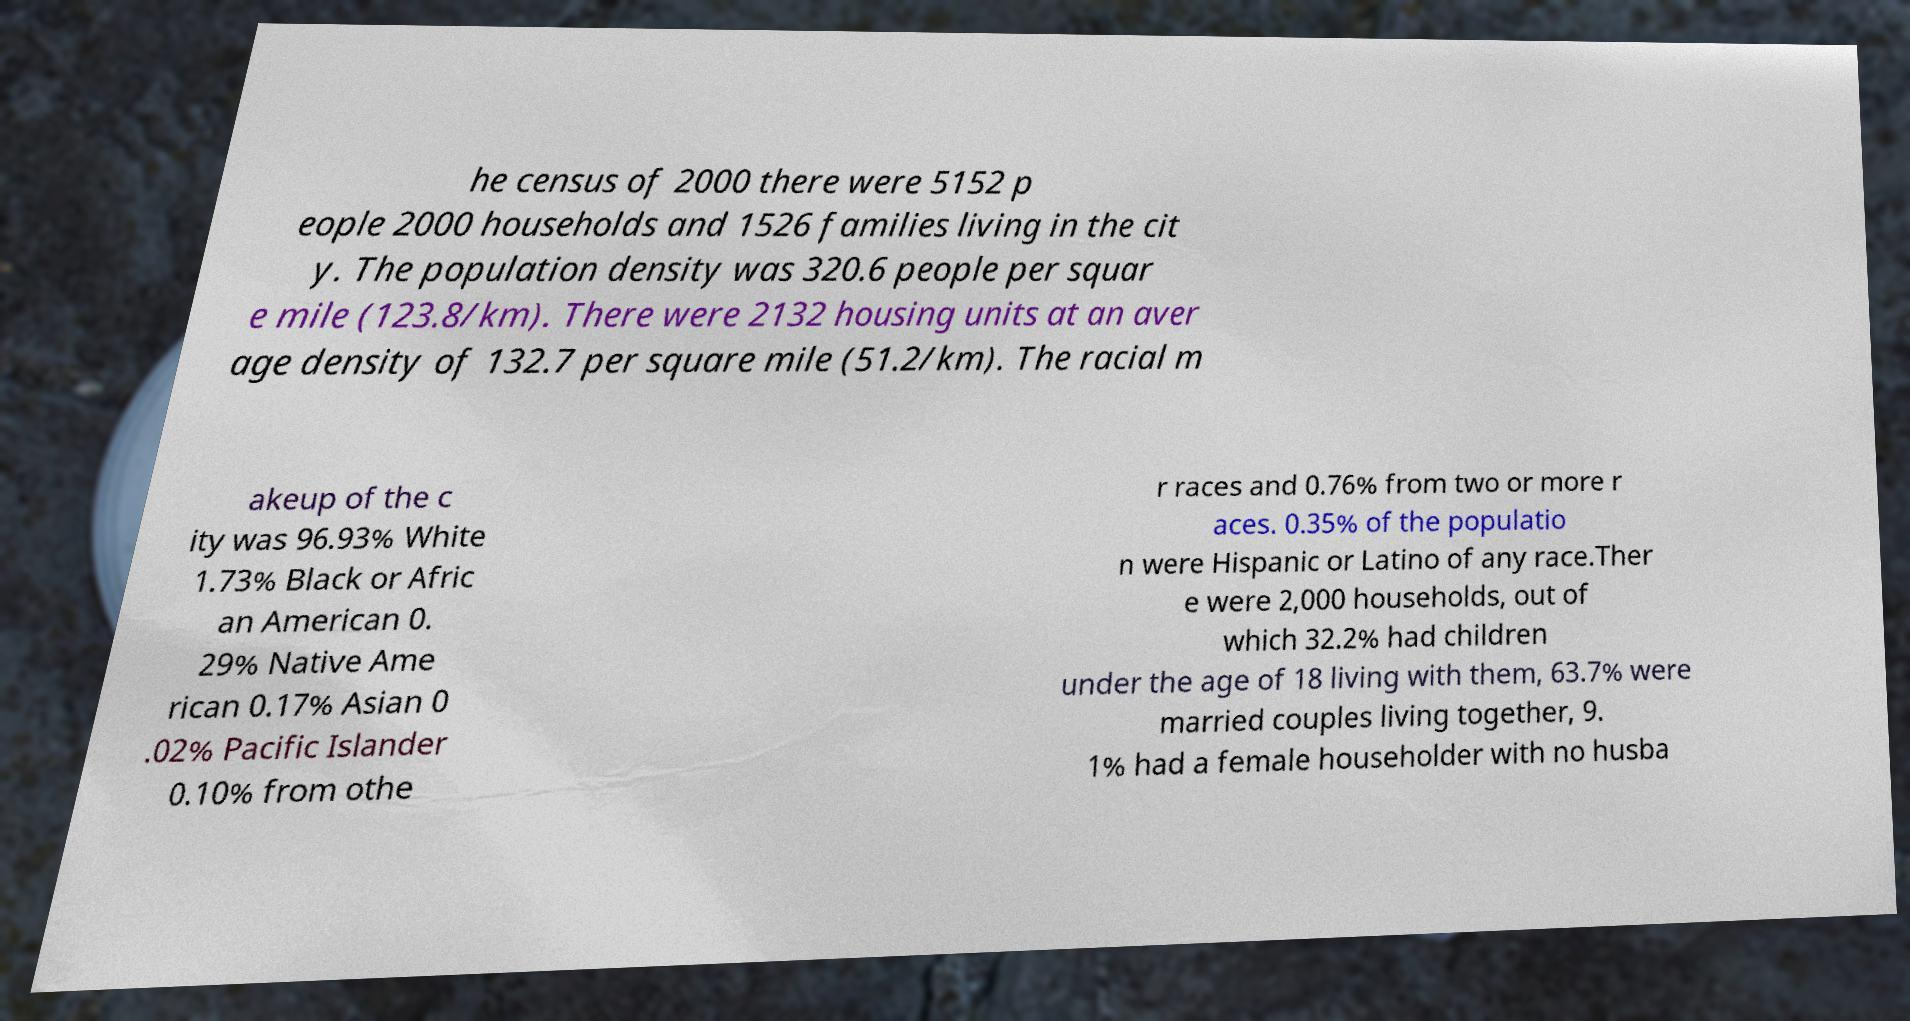Could you assist in decoding the text presented in this image and type it out clearly? he census of 2000 there were 5152 p eople 2000 households and 1526 families living in the cit y. The population density was 320.6 people per squar e mile (123.8/km). There were 2132 housing units at an aver age density of 132.7 per square mile (51.2/km). The racial m akeup of the c ity was 96.93% White 1.73% Black or Afric an American 0. 29% Native Ame rican 0.17% Asian 0 .02% Pacific Islander 0.10% from othe r races and 0.76% from two or more r aces. 0.35% of the populatio n were Hispanic or Latino of any race.Ther e were 2,000 households, out of which 32.2% had children under the age of 18 living with them, 63.7% were married couples living together, 9. 1% had a female householder with no husba 